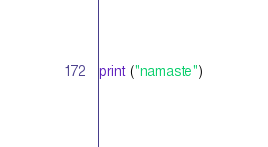Convert code to text. <code><loc_0><loc_0><loc_500><loc_500><_Python_>print ("namaste")

</code> 